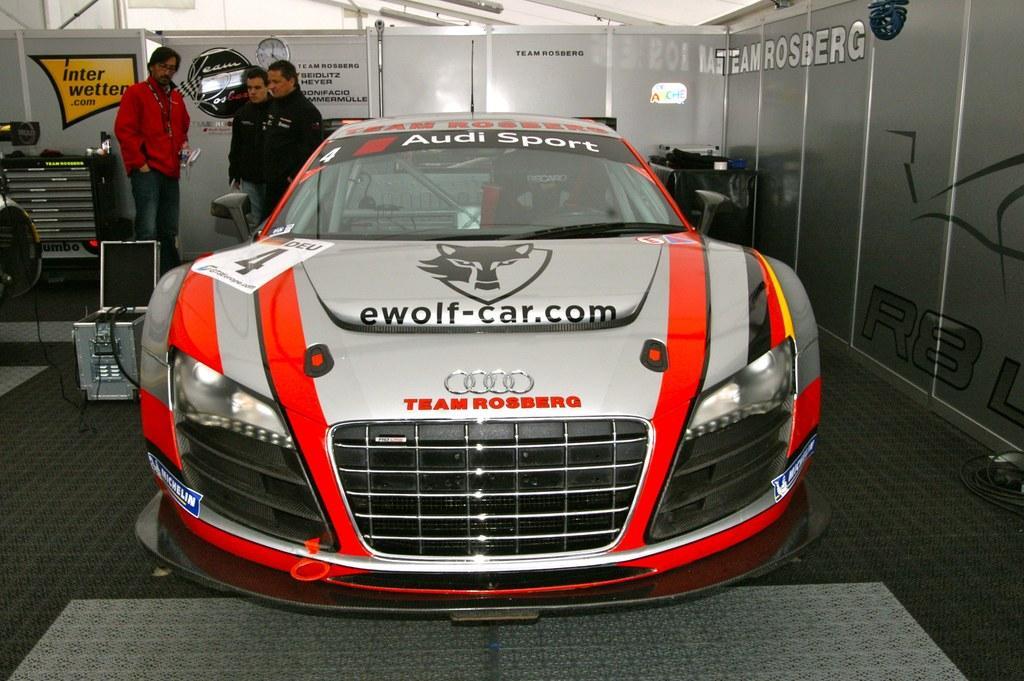Please provide a concise description of this image. Here in this picture we can see a car present on the floor and beside that we can see some people standing and watching it and we can also see other equipments also present near the car and we can also see a tool box also present and we can see a clock present on the wall. 